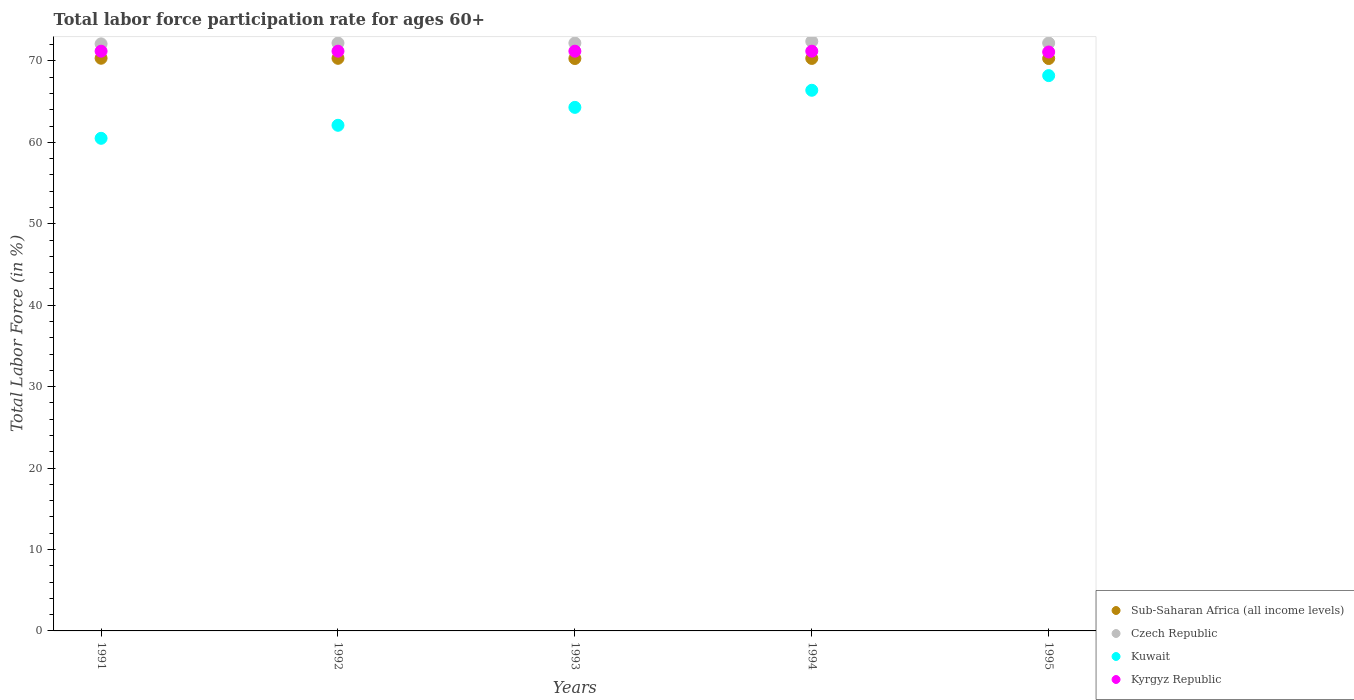How many different coloured dotlines are there?
Ensure brevity in your answer.  4. Is the number of dotlines equal to the number of legend labels?
Ensure brevity in your answer.  Yes. What is the labor force participation rate in Kuwait in 1991?
Provide a succinct answer. 60.5. Across all years, what is the maximum labor force participation rate in Kuwait?
Keep it short and to the point. 68.2. Across all years, what is the minimum labor force participation rate in Sub-Saharan Africa (all income levels)?
Make the answer very short. 70.3. What is the total labor force participation rate in Kyrgyz Republic in the graph?
Offer a very short reply. 355.9. What is the difference between the labor force participation rate in Kuwait in 1994 and that in 1995?
Your answer should be compact. -1.8. What is the difference between the labor force participation rate in Kyrgyz Republic in 1992 and the labor force participation rate in Czech Republic in 1995?
Give a very brief answer. -1. What is the average labor force participation rate in Kuwait per year?
Your response must be concise. 64.3. In the year 1994, what is the difference between the labor force participation rate in Sub-Saharan Africa (all income levels) and labor force participation rate in Kuwait?
Keep it short and to the point. 3.91. What is the ratio of the labor force participation rate in Kuwait in 1992 to that in 1994?
Your response must be concise. 0.94. Is the difference between the labor force participation rate in Sub-Saharan Africa (all income levels) in 1993 and 1994 greater than the difference between the labor force participation rate in Kuwait in 1993 and 1994?
Keep it short and to the point. Yes. What is the difference between the highest and the second highest labor force participation rate in Kuwait?
Provide a short and direct response. 1.8. What is the difference between the highest and the lowest labor force participation rate in Kyrgyz Republic?
Provide a short and direct response. 0.1. Is the sum of the labor force participation rate in Kyrgyz Republic in 1991 and 1993 greater than the maximum labor force participation rate in Czech Republic across all years?
Your answer should be very brief. Yes. Is it the case that in every year, the sum of the labor force participation rate in Czech Republic and labor force participation rate in Kuwait  is greater than the labor force participation rate in Kyrgyz Republic?
Your answer should be very brief. Yes. How many years are there in the graph?
Your answer should be very brief. 5. What is the difference between two consecutive major ticks on the Y-axis?
Provide a succinct answer. 10. Are the values on the major ticks of Y-axis written in scientific E-notation?
Give a very brief answer. No. Does the graph contain any zero values?
Offer a very short reply. No. How are the legend labels stacked?
Provide a succinct answer. Vertical. What is the title of the graph?
Your answer should be compact. Total labor force participation rate for ages 60+. Does "Australia" appear as one of the legend labels in the graph?
Your answer should be very brief. No. What is the Total Labor Force (in %) in Sub-Saharan Africa (all income levels) in 1991?
Your response must be concise. 70.33. What is the Total Labor Force (in %) in Czech Republic in 1991?
Make the answer very short. 72.1. What is the Total Labor Force (in %) of Kuwait in 1991?
Offer a very short reply. 60.5. What is the Total Labor Force (in %) in Kyrgyz Republic in 1991?
Provide a short and direct response. 71.2. What is the Total Labor Force (in %) in Sub-Saharan Africa (all income levels) in 1992?
Provide a succinct answer. 70.32. What is the Total Labor Force (in %) in Czech Republic in 1992?
Ensure brevity in your answer.  72.2. What is the Total Labor Force (in %) in Kuwait in 1992?
Give a very brief answer. 62.1. What is the Total Labor Force (in %) in Kyrgyz Republic in 1992?
Your answer should be compact. 71.2. What is the Total Labor Force (in %) of Sub-Saharan Africa (all income levels) in 1993?
Give a very brief answer. 70.3. What is the Total Labor Force (in %) of Czech Republic in 1993?
Provide a succinct answer. 72.2. What is the Total Labor Force (in %) in Kuwait in 1993?
Provide a succinct answer. 64.3. What is the Total Labor Force (in %) of Kyrgyz Republic in 1993?
Your answer should be compact. 71.2. What is the Total Labor Force (in %) in Sub-Saharan Africa (all income levels) in 1994?
Your answer should be compact. 70.31. What is the Total Labor Force (in %) of Czech Republic in 1994?
Your answer should be very brief. 72.4. What is the Total Labor Force (in %) in Kuwait in 1994?
Offer a terse response. 66.4. What is the Total Labor Force (in %) of Kyrgyz Republic in 1994?
Give a very brief answer. 71.2. What is the Total Labor Force (in %) of Sub-Saharan Africa (all income levels) in 1995?
Your answer should be compact. 70.3. What is the Total Labor Force (in %) of Czech Republic in 1995?
Keep it short and to the point. 72.2. What is the Total Labor Force (in %) of Kuwait in 1995?
Offer a very short reply. 68.2. What is the Total Labor Force (in %) of Kyrgyz Republic in 1995?
Offer a terse response. 71.1. Across all years, what is the maximum Total Labor Force (in %) of Sub-Saharan Africa (all income levels)?
Provide a short and direct response. 70.33. Across all years, what is the maximum Total Labor Force (in %) of Czech Republic?
Provide a short and direct response. 72.4. Across all years, what is the maximum Total Labor Force (in %) of Kuwait?
Ensure brevity in your answer.  68.2. Across all years, what is the maximum Total Labor Force (in %) in Kyrgyz Republic?
Keep it short and to the point. 71.2. Across all years, what is the minimum Total Labor Force (in %) in Sub-Saharan Africa (all income levels)?
Offer a very short reply. 70.3. Across all years, what is the minimum Total Labor Force (in %) in Czech Republic?
Ensure brevity in your answer.  72.1. Across all years, what is the minimum Total Labor Force (in %) of Kuwait?
Provide a succinct answer. 60.5. Across all years, what is the minimum Total Labor Force (in %) in Kyrgyz Republic?
Offer a very short reply. 71.1. What is the total Total Labor Force (in %) in Sub-Saharan Africa (all income levels) in the graph?
Your response must be concise. 351.57. What is the total Total Labor Force (in %) in Czech Republic in the graph?
Ensure brevity in your answer.  361.1. What is the total Total Labor Force (in %) in Kuwait in the graph?
Your answer should be compact. 321.5. What is the total Total Labor Force (in %) in Kyrgyz Republic in the graph?
Provide a short and direct response. 355.9. What is the difference between the Total Labor Force (in %) in Sub-Saharan Africa (all income levels) in 1991 and that in 1992?
Keep it short and to the point. 0.01. What is the difference between the Total Labor Force (in %) of Sub-Saharan Africa (all income levels) in 1991 and that in 1993?
Your answer should be very brief. 0.03. What is the difference between the Total Labor Force (in %) of Kuwait in 1991 and that in 1993?
Provide a succinct answer. -3.8. What is the difference between the Total Labor Force (in %) in Sub-Saharan Africa (all income levels) in 1991 and that in 1994?
Ensure brevity in your answer.  0.02. What is the difference between the Total Labor Force (in %) of Kyrgyz Republic in 1991 and that in 1994?
Offer a terse response. 0. What is the difference between the Total Labor Force (in %) of Sub-Saharan Africa (all income levels) in 1991 and that in 1995?
Provide a short and direct response. 0.03. What is the difference between the Total Labor Force (in %) of Czech Republic in 1991 and that in 1995?
Provide a short and direct response. -0.1. What is the difference between the Total Labor Force (in %) of Kyrgyz Republic in 1991 and that in 1995?
Your response must be concise. 0.1. What is the difference between the Total Labor Force (in %) of Sub-Saharan Africa (all income levels) in 1992 and that in 1993?
Offer a terse response. 0.03. What is the difference between the Total Labor Force (in %) of Czech Republic in 1992 and that in 1993?
Ensure brevity in your answer.  0. What is the difference between the Total Labor Force (in %) of Kuwait in 1992 and that in 1993?
Offer a very short reply. -2.2. What is the difference between the Total Labor Force (in %) of Kyrgyz Republic in 1992 and that in 1993?
Your response must be concise. 0. What is the difference between the Total Labor Force (in %) in Sub-Saharan Africa (all income levels) in 1992 and that in 1994?
Your answer should be compact. 0.01. What is the difference between the Total Labor Force (in %) of Sub-Saharan Africa (all income levels) in 1992 and that in 1995?
Your answer should be very brief. 0.02. What is the difference between the Total Labor Force (in %) of Czech Republic in 1992 and that in 1995?
Keep it short and to the point. 0. What is the difference between the Total Labor Force (in %) in Sub-Saharan Africa (all income levels) in 1993 and that in 1994?
Provide a succinct answer. -0.01. What is the difference between the Total Labor Force (in %) in Kuwait in 1993 and that in 1994?
Offer a very short reply. -2.1. What is the difference between the Total Labor Force (in %) in Sub-Saharan Africa (all income levels) in 1993 and that in 1995?
Provide a short and direct response. -0. What is the difference between the Total Labor Force (in %) of Czech Republic in 1993 and that in 1995?
Provide a succinct answer. 0. What is the difference between the Total Labor Force (in %) of Kuwait in 1993 and that in 1995?
Your answer should be very brief. -3.9. What is the difference between the Total Labor Force (in %) in Kyrgyz Republic in 1993 and that in 1995?
Your answer should be very brief. 0.1. What is the difference between the Total Labor Force (in %) in Sub-Saharan Africa (all income levels) in 1994 and that in 1995?
Provide a succinct answer. 0.01. What is the difference between the Total Labor Force (in %) in Kuwait in 1994 and that in 1995?
Your answer should be very brief. -1.8. What is the difference between the Total Labor Force (in %) of Kyrgyz Republic in 1994 and that in 1995?
Ensure brevity in your answer.  0.1. What is the difference between the Total Labor Force (in %) of Sub-Saharan Africa (all income levels) in 1991 and the Total Labor Force (in %) of Czech Republic in 1992?
Your answer should be compact. -1.87. What is the difference between the Total Labor Force (in %) of Sub-Saharan Africa (all income levels) in 1991 and the Total Labor Force (in %) of Kuwait in 1992?
Keep it short and to the point. 8.23. What is the difference between the Total Labor Force (in %) in Sub-Saharan Africa (all income levels) in 1991 and the Total Labor Force (in %) in Kyrgyz Republic in 1992?
Give a very brief answer. -0.87. What is the difference between the Total Labor Force (in %) of Czech Republic in 1991 and the Total Labor Force (in %) of Kuwait in 1992?
Provide a succinct answer. 10. What is the difference between the Total Labor Force (in %) of Czech Republic in 1991 and the Total Labor Force (in %) of Kyrgyz Republic in 1992?
Provide a short and direct response. 0.9. What is the difference between the Total Labor Force (in %) of Sub-Saharan Africa (all income levels) in 1991 and the Total Labor Force (in %) of Czech Republic in 1993?
Offer a terse response. -1.87. What is the difference between the Total Labor Force (in %) of Sub-Saharan Africa (all income levels) in 1991 and the Total Labor Force (in %) of Kuwait in 1993?
Offer a terse response. 6.03. What is the difference between the Total Labor Force (in %) in Sub-Saharan Africa (all income levels) in 1991 and the Total Labor Force (in %) in Kyrgyz Republic in 1993?
Offer a very short reply. -0.87. What is the difference between the Total Labor Force (in %) in Czech Republic in 1991 and the Total Labor Force (in %) in Kuwait in 1993?
Offer a terse response. 7.8. What is the difference between the Total Labor Force (in %) in Kuwait in 1991 and the Total Labor Force (in %) in Kyrgyz Republic in 1993?
Ensure brevity in your answer.  -10.7. What is the difference between the Total Labor Force (in %) of Sub-Saharan Africa (all income levels) in 1991 and the Total Labor Force (in %) of Czech Republic in 1994?
Provide a short and direct response. -2.07. What is the difference between the Total Labor Force (in %) in Sub-Saharan Africa (all income levels) in 1991 and the Total Labor Force (in %) in Kuwait in 1994?
Give a very brief answer. 3.93. What is the difference between the Total Labor Force (in %) in Sub-Saharan Africa (all income levels) in 1991 and the Total Labor Force (in %) in Kyrgyz Republic in 1994?
Keep it short and to the point. -0.87. What is the difference between the Total Labor Force (in %) of Czech Republic in 1991 and the Total Labor Force (in %) of Kuwait in 1994?
Offer a very short reply. 5.7. What is the difference between the Total Labor Force (in %) in Czech Republic in 1991 and the Total Labor Force (in %) in Kyrgyz Republic in 1994?
Ensure brevity in your answer.  0.9. What is the difference between the Total Labor Force (in %) in Kuwait in 1991 and the Total Labor Force (in %) in Kyrgyz Republic in 1994?
Provide a succinct answer. -10.7. What is the difference between the Total Labor Force (in %) of Sub-Saharan Africa (all income levels) in 1991 and the Total Labor Force (in %) of Czech Republic in 1995?
Keep it short and to the point. -1.87. What is the difference between the Total Labor Force (in %) of Sub-Saharan Africa (all income levels) in 1991 and the Total Labor Force (in %) of Kuwait in 1995?
Your answer should be very brief. 2.13. What is the difference between the Total Labor Force (in %) in Sub-Saharan Africa (all income levels) in 1991 and the Total Labor Force (in %) in Kyrgyz Republic in 1995?
Offer a terse response. -0.77. What is the difference between the Total Labor Force (in %) in Czech Republic in 1991 and the Total Labor Force (in %) in Kuwait in 1995?
Give a very brief answer. 3.9. What is the difference between the Total Labor Force (in %) in Sub-Saharan Africa (all income levels) in 1992 and the Total Labor Force (in %) in Czech Republic in 1993?
Offer a terse response. -1.88. What is the difference between the Total Labor Force (in %) of Sub-Saharan Africa (all income levels) in 1992 and the Total Labor Force (in %) of Kuwait in 1993?
Offer a terse response. 6.02. What is the difference between the Total Labor Force (in %) of Sub-Saharan Africa (all income levels) in 1992 and the Total Labor Force (in %) of Kyrgyz Republic in 1993?
Offer a very short reply. -0.88. What is the difference between the Total Labor Force (in %) in Czech Republic in 1992 and the Total Labor Force (in %) in Kuwait in 1993?
Provide a short and direct response. 7.9. What is the difference between the Total Labor Force (in %) in Czech Republic in 1992 and the Total Labor Force (in %) in Kyrgyz Republic in 1993?
Ensure brevity in your answer.  1. What is the difference between the Total Labor Force (in %) of Kuwait in 1992 and the Total Labor Force (in %) of Kyrgyz Republic in 1993?
Offer a terse response. -9.1. What is the difference between the Total Labor Force (in %) in Sub-Saharan Africa (all income levels) in 1992 and the Total Labor Force (in %) in Czech Republic in 1994?
Keep it short and to the point. -2.08. What is the difference between the Total Labor Force (in %) of Sub-Saharan Africa (all income levels) in 1992 and the Total Labor Force (in %) of Kuwait in 1994?
Your response must be concise. 3.92. What is the difference between the Total Labor Force (in %) of Sub-Saharan Africa (all income levels) in 1992 and the Total Labor Force (in %) of Kyrgyz Republic in 1994?
Your answer should be very brief. -0.88. What is the difference between the Total Labor Force (in %) of Sub-Saharan Africa (all income levels) in 1992 and the Total Labor Force (in %) of Czech Republic in 1995?
Provide a short and direct response. -1.88. What is the difference between the Total Labor Force (in %) in Sub-Saharan Africa (all income levels) in 1992 and the Total Labor Force (in %) in Kuwait in 1995?
Provide a short and direct response. 2.12. What is the difference between the Total Labor Force (in %) in Sub-Saharan Africa (all income levels) in 1992 and the Total Labor Force (in %) in Kyrgyz Republic in 1995?
Give a very brief answer. -0.78. What is the difference between the Total Labor Force (in %) in Sub-Saharan Africa (all income levels) in 1993 and the Total Labor Force (in %) in Czech Republic in 1994?
Your answer should be compact. -2.1. What is the difference between the Total Labor Force (in %) of Sub-Saharan Africa (all income levels) in 1993 and the Total Labor Force (in %) of Kuwait in 1994?
Give a very brief answer. 3.9. What is the difference between the Total Labor Force (in %) in Sub-Saharan Africa (all income levels) in 1993 and the Total Labor Force (in %) in Kyrgyz Republic in 1994?
Your response must be concise. -0.9. What is the difference between the Total Labor Force (in %) of Czech Republic in 1993 and the Total Labor Force (in %) of Kuwait in 1994?
Ensure brevity in your answer.  5.8. What is the difference between the Total Labor Force (in %) in Czech Republic in 1993 and the Total Labor Force (in %) in Kyrgyz Republic in 1994?
Provide a short and direct response. 1. What is the difference between the Total Labor Force (in %) in Kuwait in 1993 and the Total Labor Force (in %) in Kyrgyz Republic in 1994?
Offer a terse response. -6.9. What is the difference between the Total Labor Force (in %) of Sub-Saharan Africa (all income levels) in 1993 and the Total Labor Force (in %) of Czech Republic in 1995?
Your answer should be compact. -1.9. What is the difference between the Total Labor Force (in %) in Sub-Saharan Africa (all income levels) in 1993 and the Total Labor Force (in %) in Kuwait in 1995?
Keep it short and to the point. 2.1. What is the difference between the Total Labor Force (in %) in Sub-Saharan Africa (all income levels) in 1993 and the Total Labor Force (in %) in Kyrgyz Republic in 1995?
Offer a very short reply. -0.8. What is the difference between the Total Labor Force (in %) in Czech Republic in 1993 and the Total Labor Force (in %) in Kuwait in 1995?
Keep it short and to the point. 4. What is the difference between the Total Labor Force (in %) of Kuwait in 1993 and the Total Labor Force (in %) of Kyrgyz Republic in 1995?
Offer a terse response. -6.8. What is the difference between the Total Labor Force (in %) in Sub-Saharan Africa (all income levels) in 1994 and the Total Labor Force (in %) in Czech Republic in 1995?
Your response must be concise. -1.89. What is the difference between the Total Labor Force (in %) of Sub-Saharan Africa (all income levels) in 1994 and the Total Labor Force (in %) of Kuwait in 1995?
Your answer should be very brief. 2.11. What is the difference between the Total Labor Force (in %) in Sub-Saharan Africa (all income levels) in 1994 and the Total Labor Force (in %) in Kyrgyz Republic in 1995?
Offer a terse response. -0.79. What is the difference between the Total Labor Force (in %) in Czech Republic in 1994 and the Total Labor Force (in %) in Kuwait in 1995?
Your answer should be very brief. 4.2. What is the difference between the Total Labor Force (in %) in Czech Republic in 1994 and the Total Labor Force (in %) in Kyrgyz Republic in 1995?
Your answer should be very brief. 1.3. What is the difference between the Total Labor Force (in %) of Kuwait in 1994 and the Total Labor Force (in %) of Kyrgyz Republic in 1995?
Offer a very short reply. -4.7. What is the average Total Labor Force (in %) of Sub-Saharan Africa (all income levels) per year?
Make the answer very short. 70.31. What is the average Total Labor Force (in %) in Czech Republic per year?
Your response must be concise. 72.22. What is the average Total Labor Force (in %) in Kuwait per year?
Give a very brief answer. 64.3. What is the average Total Labor Force (in %) of Kyrgyz Republic per year?
Offer a very short reply. 71.18. In the year 1991, what is the difference between the Total Labor Force (in %) of Sub-Saharan Africa (all income levels) and Total Labor Force (in %) of Czech Republic?
Offer a very short reply. -1.77. In the year 1991, what is the difference between the Total Labor Force (in %) of Sub-Saharan Africa (all income levels) and Total Labor Force (in %) of Kuwait?
Provide a short and direct response. 9.83. In the year 1991, what is the difference between the Total Labor Force (in %) of Sub-Saharan Africa (all income levels) and Total Labor Force (in %) of Kyrgyz Republic?
Your answer should be very brief. -0.87. In the year 1991, what is the difference between the Total Labor Force (in %) of Kuwait and Total Labor Force (in %) of Kyrgyz Republic?
Ensure brevity in your answer.  -10.7. In the year 1992, what is the difference between the Total Labor Force (in %) of Sub-Saharan Africa (all income levels) and Total Labor Force (in %) of Czech Republic?
Your response must be concise. -1.88. In the year 1992, what is the difference between the Total Labor Force (in %) in Sub-Saharan Africa (all income levels) and Total Labor Force (in %) in Kuwait?
Provide a short and direct response. 8.22. In the year 1992, what is the difference between the Total Labor Force (in %) in Sub-Saharan Africa (all income levels) and Total Labor Force (in %) in Kyrgyz Republic?
Offer a terse response. -0.88. In the year 1992, what is the difference between the Total Labor Force (in %) of Czech Republic and Total Labor Force (in %) of Kuwait?
Your answer should be very brief. 10.1. In the year 1993, what is the difference between the Total Labor Force (in %) in Sub-Saharan Africa (all income levels) and Total Labor Force (in %) in Czech Republic?
Give a very brief answer. -1.9. In the year 1993, what is the difference between the Total Labor Force (in %) in Sub-Saharan Africa (all income levels) and Total Labor Force (in %) in Kuwait?
Offer a terse response. 6. In the year 1993, what is the difference between the Total Labor Force (in %) of Sub-Saharan Africa (all income levels) and Total Labor Force (in %) of Kyrgyz Republic?
Provide a short and direct response. -0.9. In the year 1993, what is the difference between the Total Labor Force (in %) in Czech Republic and Total Labor Force (in %) in Kuwait?
Keep it short and to the point. 7.9. In the year 1993, what is the difference between the Total Labor Force (in %) in Czech Republic and Total Labor Force (in %) in Kyrgyz Republic?
Give a very brief answer. 1. In the year 1994, what is the difference between the Total Labor Force (in %) in Sub-Saharan Africa (all income levels) and Total Labor Force (in %) in Czech Republic?
Your answer should be compact. -2.09. In the year 1994, what is the difference between the Total Labor Force (in %) of Sub-Saharan Africa (all income levels) and Total Labor Force (in %) of Kuwait?
Provide a short and direct response. 3.91. In the year 1994, what is the difference between the Total Labor Force (in %) of Sub-Saharan Africa (all income levels) and Total Labor Force (in %) of Kyrgyz Republic?
Your answer should be compact. -0.89. In the year 1994, what is the difference between the Total Labor Force (in %) of Czech Republic and Total Labor Force (in %) of Kyrgyz Republic?
Ensure brevity in your answer.  1.2. In the year 1995, what is the difference between the Total Labor Force (in %) of Sub-Saharan Africa (all income levels) and Total Labor Force (in %) of Czech Republic?
Offer a terse response. -1.9. In the year 1995, what is the difference between the Total Labor Force (in %) in Sub-Saharan Africa (all income levels) and Total Labor Force (in %) in Kuwait?
Your response must be concise. 2.1. In the year 1995, what is the difference between the Total Labor Force (in %) of Sub-Saharan Africa (all income levels) and Total Labor Force (in %) of Kyrgyz Republic?
Your answer should be very brief. -0.8. In the year 1995, what is the difference between the Total Labor Force (in %) of Czech Republic and Total Labor Force (in %) of Kyrgyz Republic?
Provide a short and direct response. 1.1. What is the ratio of the Total Labor Force (in %) in Czech Republic in 1991 to that in 1992?
Offer a terse response. 1. What is the ratio of the Total Labor Force (in %) of Kuwait in 1991 to that in 1992?
Your answer should be very brief. 0.97. What is the ratio of the Total Labor Force (in %) of Kyrgyz Republic in 1991 to that in 1992?
Offer a terse response. 1. What is the ratio of the Total Labor Force (in %) of Czech Republic in 1991 to that in 1993?
Your response must be concise. 1. What is the ratio of the Total Labor Force (in %) of Kuwait in 1991 to that in 1993?
Your answer should be very brief. 0.94. What is the ratio of the Total Labor Force (in %) of Sub-Saharan Africa (all income levels) in 1991 to that in 1994?
Provide a short and direct response. 1. What is the ratio of the Total Labor Force (in %) in Czech Republic in 1991 to that in 1994?
Your answer should be compact. 1. What is the ratio of the Total Labor Force (in %) of Kuwait in 1991 to that in 1994?
Offer a terse response. 0.91. What is the ratio of the Total Labor Force (in %) in Sub-Saharan Africa (all income levels) in 1991 to that in 1995?
Offer a very short reply. 1. What is the ratio of the Total Labor Force (in %) of Czech Republic in 1991 to that in 1995?
Give a very brief answer. 1. What is the ratio of the Total Labor Force (in %) in Kuwait in 1991 to that in 1995?
Your answer should be very brief. 0.89. What is the ratio of the Total Labor Force (in %) of Kyrgyz Republic in 1991 to that in 1995?
Your answer should be very brief. 1. What is the ratio of the Total Labor Force (in %) in Czech Republic in 1992 to that in 1993?
Make the answer very short. 1. What is the ratio of the Total Labor Force (in %) in Kuwait in 1992 to that in 1993?
Ensure brevity in your answer.  0.97. What is the ratio of the Total Labor Force (in %) of Kuwait in 1992 to that in 1994?
Keep it short and to the point. 0.94. What is the ratio of the Total Labor Force (in %) of Sub-Saharan Africa (all income levels) in 1992 to that in 1995?
Provide a succinct answer. 1. What is the ratio of the Total Labor Force (in %) in Czech Republic in 1992 to that in 1995?
Ensure brevity in your answer.  1. What is the ratio of the Total Labor Force (in %) in Kuwait in 1992 to that in 1995?
Offer a very short reply. 0.91. What is the ratio of the Total Labor Force (in %) in Czech Republic in 1993 to that in 1994?
Provide a short and direct response. 1. What is the ratio of the Total Labor Force (in %) in Kuwait in 1993 to that in 1994?
Make the answer very short. 0.97. What is the ratio of the Total Labor Force (in %) in Kyrgyz Republic in 1993 to that in 1994?
Offer a terse response. 1. What is the ratio of the Total Labor Force (in %) in Czech Republic in 1993 to that in 1995?
Your answer should be very brief. 1. What is the ratio of the Total Labor Force (in %) in Kuwait in 1993 to that in 1995?
Your answer should be compact. 0.94. What is the ratio of the Total Labor Force (in %) of Kyrgyz Republic in 1993 to that in 1995?
Provide a short and direct response. 1. What is the ratio of the Total Labor Force (in %) in Czech Republic in 1994 to that in 1995?
Your answer should be very brief. 1. What is the ratio of the Total Labor Force (in %) in Kuwait in 1994 to that in 1995?
Provide a succinct answer. 0.97. What is the difference between the highest and the second highest Total Labor Force (in %) in Sub-Saharan Africa (all income levels)?
Your response must be concise. 0.01. What is the difference between the highest and the second highest Total Labor Force (in %) of Kyrgyz Republic?
Your response must be concise. 0. What is the difference between the highest and the lowest Total Labor Force (in %) of Sub-Saharan Africa (all income levels)?
Offer a terse response. 0.03. What is the difference between the highest and the lowest Total Labor Force (in %) in Czech Republic?
Provide a succinct answer. 0.3. What is the difference between the highest and the lowest Total Labor Force (in %) of Kuwait?
Keep it short and to the point. 7.7. 